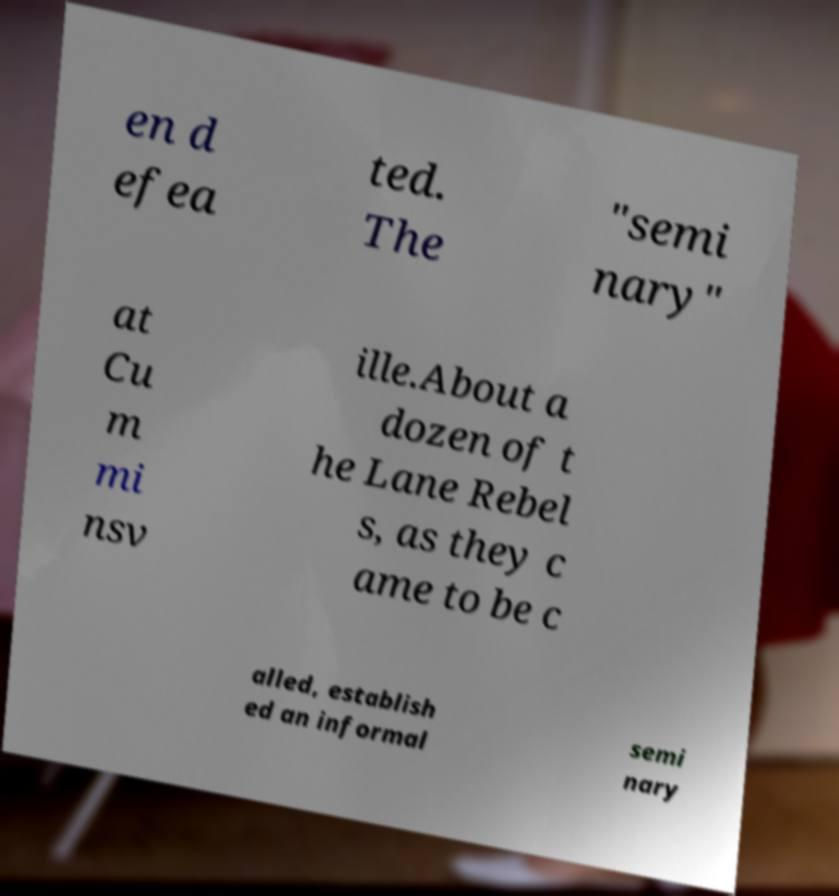There's text embedded in this image that I need extracted. Can you transcribe it verbatim? en d efea ted. The "semi nary" at Cu m mi nsv ille.About a dozen of t he Lane Rebel s, as they c ame to be c alled, establish ed an informal semi nary 